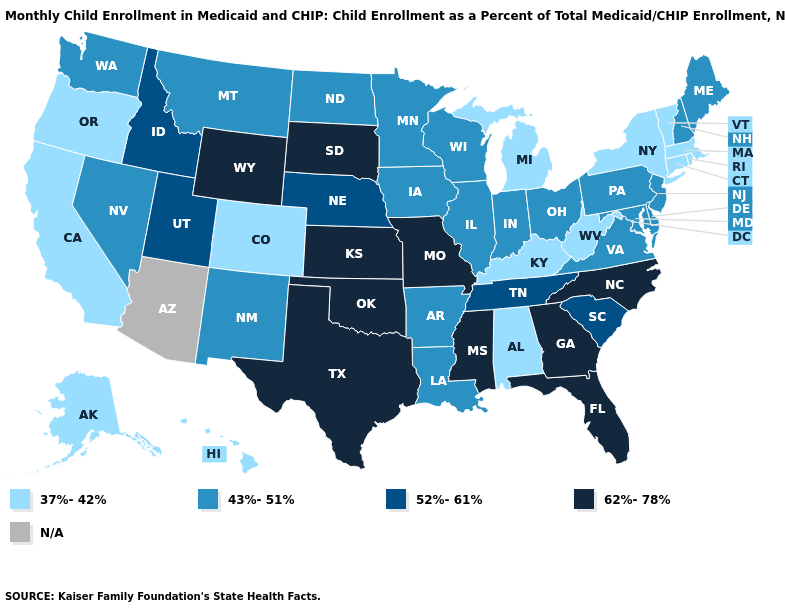Among the states that border Arkansas , which have the lowest value?
Quick response, please. Louisiana. What is the highest value in the Northeast ?
Short answer required. 43%-51%. Among the states that border Georgia , which have the highest value?
Write a very short answer. Florida, North Carolina. Does the first symbol in the legend represent the smallest category?
Quick response, please. Yes. Name the states that have a value in the range 62%-78%?
Give a very brief answer. Florida, Georgia, Kansas, Mississippi, Missouri, North Carolina, Oklahoma, South Dakota, Texas, Wyoming. What is the lowest value in the USA?
Write a very short answer. 37%-42%. What is the value of Mississippi?
Answer briefly. 62%-78%. Among the states that border California , does Oregon have the lowest value?
Write a very short answer. Yes. Does Michigan have the lowest value in the MidWest?
Be succinct. Yes. What is the value of North Dakota?
Concise answer only. 43%-51%. Name the states that have a value in the range 52%-61%?
Quick response, please. Idaho, Nebraska, South Carolina, Tennessee, Utah. Does New York have the lowest value in the USA?
Short answer required. Yes. Among the states that border Oklahoma , does New Mexico have the lowest value?
Answer briefly. No. Is the legend a continuous bar?
Give a very brief answer. No. 